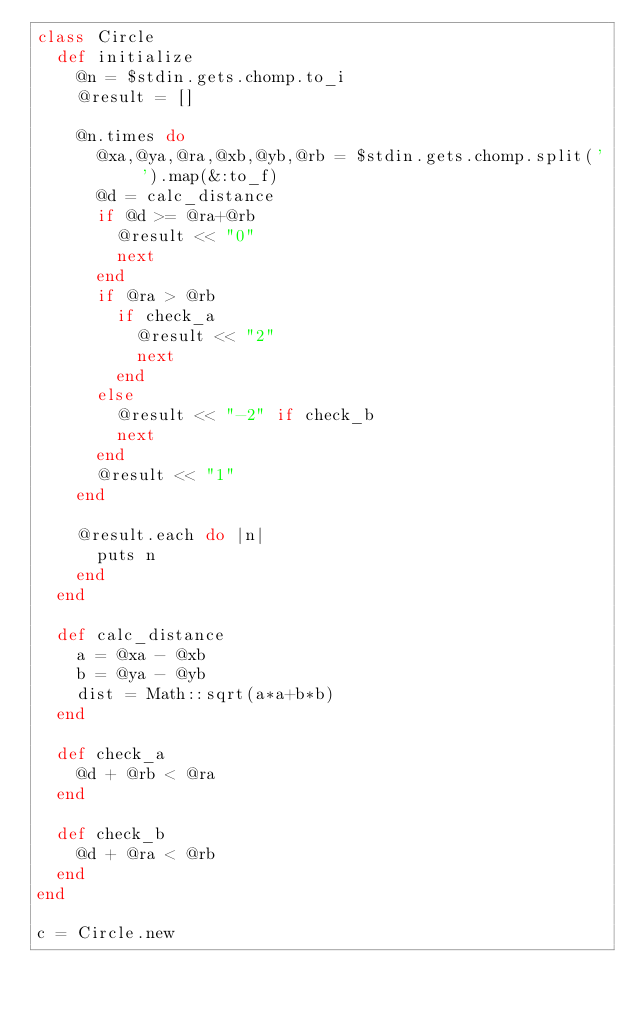Convert code to text. <code><loc_0><loc_0><loc_500><loc_500><_Ruby_>class Circle
  def initialize
    @n = $stdin.gets.chomp.to_i
    @result = []

    @n.times do
      @xa,@ya,@ra,@xb,@yb,@rb = $stdin.gets.chomp.split(' ').map(&:to_f)
      @d = calc_distance
      if @d >= @ra+@rb
        @result << "0"
        next
      end
      if @ra > @rb
        if check_a
          @result << "2"
          next
        end
      else
        @result << "-2" if check_b
        next
      end  
      @result << "1"
    end

    @result.each do |n|
      puts n
    end
  end

  def calc_distance
    a = @xa - @xb
    b = @ya - @yb
    dist = Math::sqrt(a*a+b*b)
  end

  def check_a
    @d + @rb < @ra
  end

  def check_b
    @d + @ra < @rb
  end
end

c = Circle.new</code> 